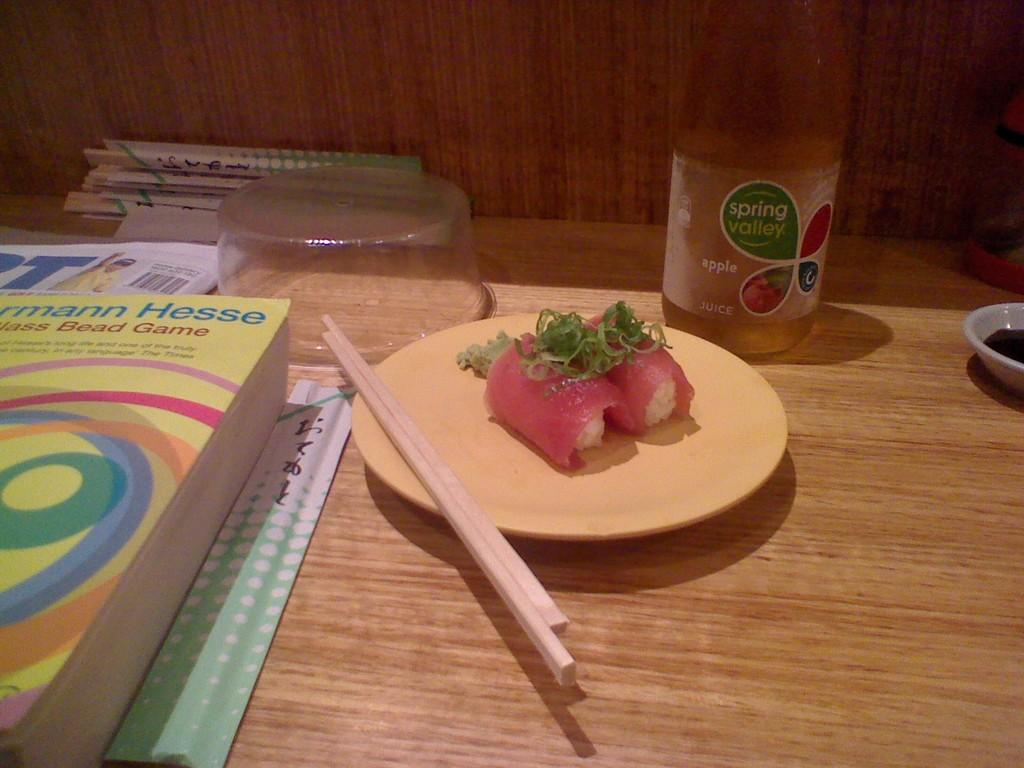Provide a one-sentence caption for the provided image. A wood table with a plate of sushi and a bottle of Spring Valley apple juice on it. 